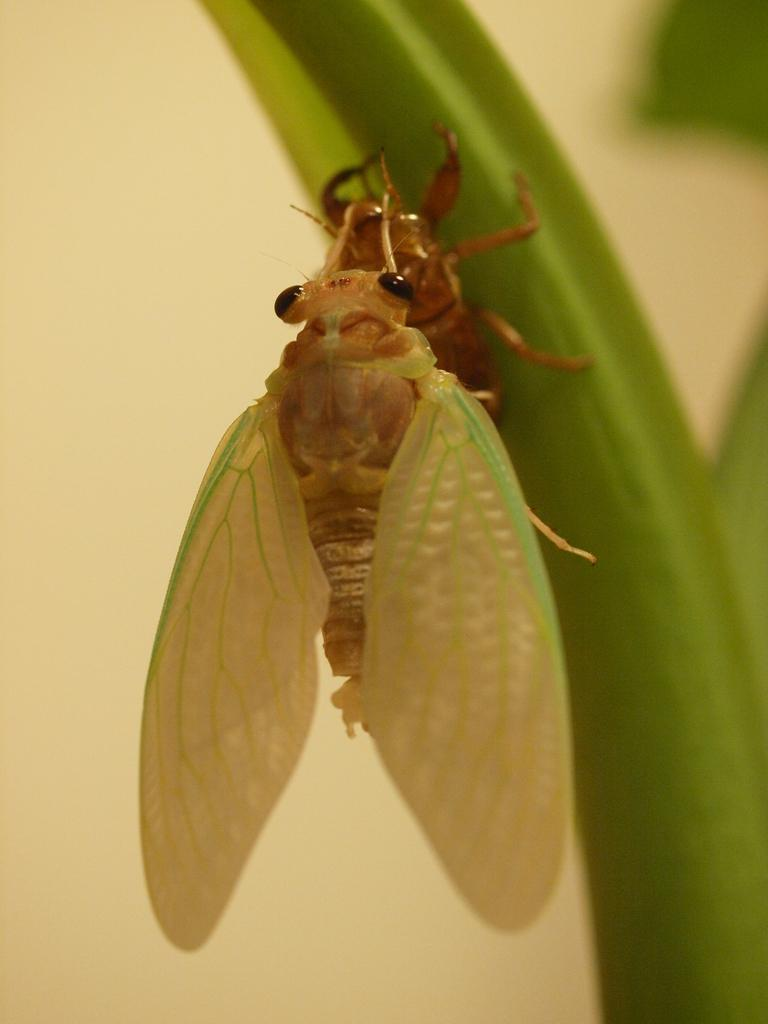What is present in the picture? There is an insect in the picture. Where is the insect located? The insect is on the stem of a plant. What can be seen in the background of the image? There appears to be a wall in the background of the image. What is the rate at which the crayon is being used in the image? There is no crayon present in the image, so it is not possible to determine the rate at which it is being used. 